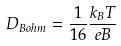<formula> <loc_0><loc_0><loc_500><loc_500>D _ { B o h m } = \frac { 1 } { 1 6 } \frac { k _ { B } T } { e B }</formula> 